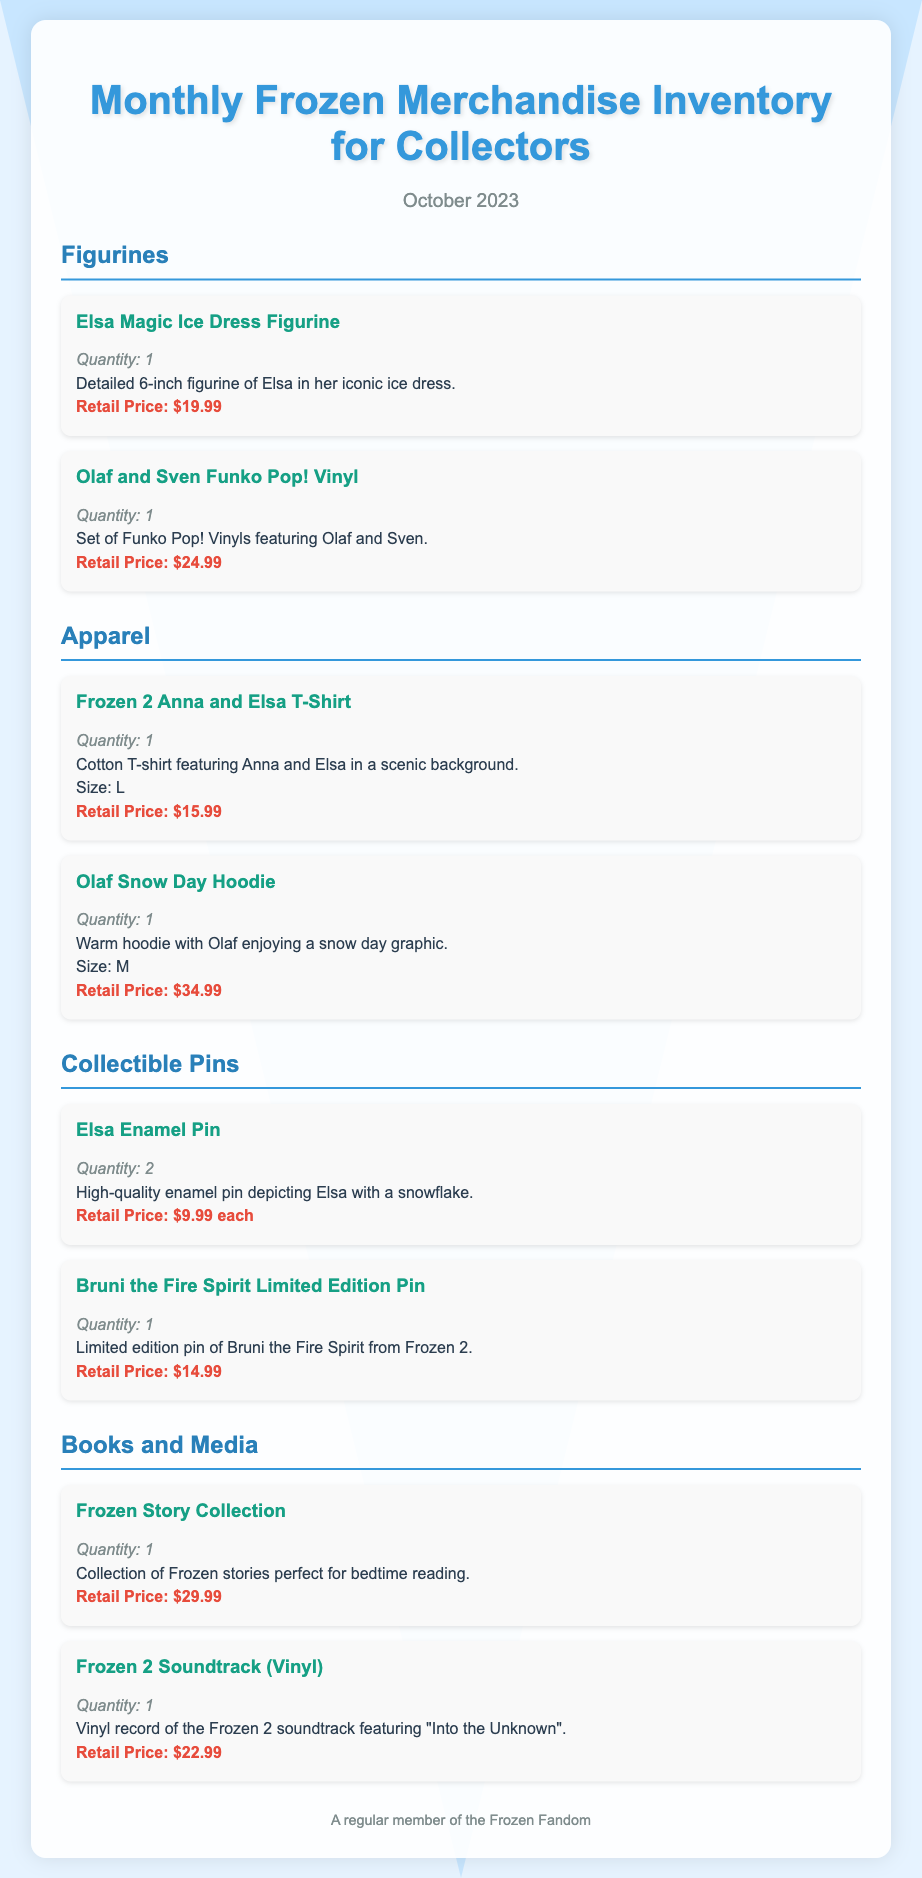What is the title of the document? The title of the document is displayed prominently at the top of the content.
Answer: Monthly Frozen Merchandise Inventory for Collectors In what month and year is this inventory for? The document clearly states the date at the center of the content.
Answer: October 2023 How many Elsa Enamel Pins are listed? The inventory specifies the quantity of Elsa Enamel Pins available.
Answer: 2 What is the retail price of the Olaf Snow Day Hoodie? The document mentions the price associated with the specific product.
Answer: $34.99 Which figurine features Olaf and Sven? The product category lists this specific figurine combination under figurines.
Answer: Olaf and Sven Funko Pop! Vinyl What size is the Frozen 2 Anna and Elsa T-Shirt? The size of the T-shirt is mentioned in the description of the product.
Answer: L What type of media is the "Frozen 2 Soundtrack"? The document specifies the format of the media in its title.
Answer: Vinyl Which item has a retail price of $14.99? The document includes this price for a specific collectible pin.
Answer: Bruni the Fire Spirit Limited Edition Pin What is the quantity of the Frozen Story Collection? The document provides the quantity for each listed item.
Answer: 1 